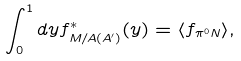Convert formula to latex. <formula><loc_0><loc_0><loc_500><loc_500>\int _ { 0 } ^ { 1 } d y f _ { M / A ( A ^ { \prime } ) } ^ { * } ( y ) = \langle f _ { \pi ^ { 0 } N } \rangle ,</formula> 